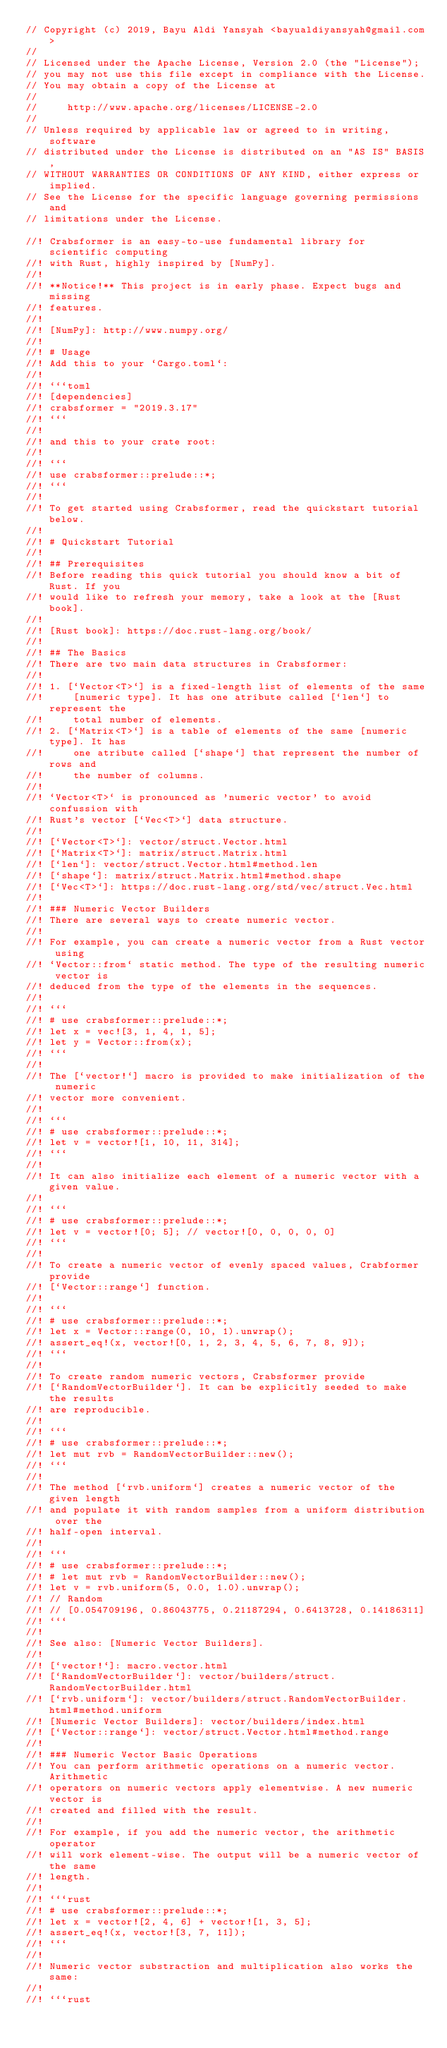Convert code to text. <code><loc_0><loc_0><loc_500><loc_500><_Rust_>// Copyright (c) 2019, Bayu Aldi Yansyah <bayualdiyansyah@gmail.com>
//
// Licensed under the Apache License, Version 2.0 (the "License");
// you may not use this file except in compliance with the License.
// You may obtain a copy of the License at
//
//     http://www.apache.org/licenses/LICENSE-2.0
//
// Unless required by applicable law or agreed to in writing, software
// distributed under the License is distributed on an "AS IS" BASIS,
// WITHOUT WARRANTIES OR CONDITIONS OF ANY KIND, either express or implied.
// See the License for the specific language governing permissions and
// limitations under the License.

//! Crabsformer is an easy-to-use fundamental library for scientific computing
//! with Rust, highly inspired by [NumPy].
//!
//! **Notice!** This project is in early phase. Expect bugs and missing
//! features.
//!
//! [NumPy]: http://www.numpy.org/
//!
//! # Usage
//! Add this to your `Cargo.toml`:
//!
//! ```toml
//! [dependencies]
//! crabsformer = "2019.3.17"
//! ```
//!
//! and this to your crate root:
//!
//! ```
//! use crabsformer::prelude::*;
//! ```
//!
//! To get started using Crabsformer, read the quickstart tutorial below.
//!
//! # Quickstart Tutorial
//!
//! ## Prerequisites
//! Before reading this quick tutorial you should know a bit of Rust. If you
//! would like to refresh your memory, take a look at the [Rust book].
//!
//! [Rust book]: https://doc.rust-lang.org/book/
//!
//! ## The Basics
//! There are two main data structures in Crabsformer:
//!
//! 1. [`Vector<T>`] is a fixed-length list of elements of the same
//!     [numeric type]. It has one atribute called [`len`] to represent the
//!     total number of elements.
//! 2. [`Matrix<T>`] is a table of elements of the same [numeric type]. It has
//!     one atribute called [`shape`] that represent the number of rows and
//!     the number of columns.
//!
//! `Vector<T>` is pronounced as 'numeric vector' to avoid confussion with
//! Rust's vector [`Vec<T>`] data structure.
//!
//! [`Vector<T>`]: vector/struct.Vector.html
//! [`Matrix<T>`]: matrix/struct.Matrix.html
//! [`len`]: vector/struct.Vector.html#method.len
//! [`shape`]: matrix/struct.Matrix.html#method.shape
//! [`Vec<T>`]: https://doc.rust-lang.org/std/vec/struct.Vec.html
//!
//! ### Numeric Vector Builders
//! There are several ways to create numeric vector.
//!
//! For example, you can create a numeric vector from a Rust vector using
//! `Vector::from` static method. The type of the resulting numeric vector is
//! deduced from the type of the elements in the sequences.
//!
//! ```
//! # use crabsformer::prelude::*;
//! let x = vec![3, 1, 4, 1, 5];
//! let y = Vector::from(x);
//! ```
//!
//! The [`vector!`] macro is provided to make initialization of the numeric
//! vector more convenient.
//!
//! ```
//! # use crabsformer::prelude::*;
//! let v = vector![1, 10, 11, 314];
//! ```
//!
//! It can also initialize each element of a numeric vector with a given value.
//!
//! ```
//! # use crabsformer::prelude::*;
//! let v = vector![0; 5]; // vector![0, 0, 0, 0, 0]
//! ```
//!
//! To create a numeric vector of evenly spaced values, Crabformer provide
//! [`Vector::range`] function.
//!
//! ```
//! # use crabsformer::prelude::*;
//! let x = Vector::range(0, 10, 1).unwrap();
//! assert_eq!(x, vector![0, 1, 2, 3, 4, 5, 6, 7, 8, 9]);
//! ```
//!
//! To create random numeric vectors, Crabsformer provide
//! [`RandomVectorBuilder`]. It can be explicitly seeded to make the results
//! are reproducible.
//!
//! ```
//! # use crabsformer::prelude::*;
//! let mut rvb = RandomVectorBuilder::new();
//! ```
//!
//! The method [`rvb.uniform`] creates a numeric vector of the given length
//! and populate it with random samples from a uniform distribution over the
//! half-open interval.
//!
//! ```
//! # use crabsformer::prelude::*;
//! # let mut rvb = RandomVectorBuilder::new();
//! let v = rvb.uniform(5, 0.0, 1.0).unwrap();
//! // Random
//! // [0.054709196, 0.86043775, 0.21187294, 0.6413728, 0.14186311]
//! ```
//!
//! See also: [Numeric Vector Builders].
//!
//! [`vector!`]: macro.vector.html
//! [`RandomVectorBuilder`]: vector/builders/struct.RandomVectorBuilder.html
//! [`rvb.uniform`]: vector/builders/struct.RandomVectorBuilder.html#method.uniform
//! [Numeric Vector Builders]: vector/builders/index.html
//! [`Vector::range`]: vector/struct.Vector.html#method.range
//!
//! ### Numeric Vector Basic Operations
//! You can perform arithmetic operations on a numeric vector. Arithmetic
//! operators on numeric vectors apply elementwise. A new numeric vector is
//! created and filled with the result.
//!
//! For example, if you add the numeric vector, the arithmetic operator
//! will work element-wise. The output will be a numeric vector of the same
//! length.
//!
//! ```rust
//! # use crabsformer::prelude::*;
//! let x = vector![2, 4, 6] + vector![1, 3, 5];
//! assert_eq!(x, vector![3, 7, 11]);
//! ```
//!
//! Numeric vector substraction and multiplication also works the same:
//!
//! ```rust</code> 